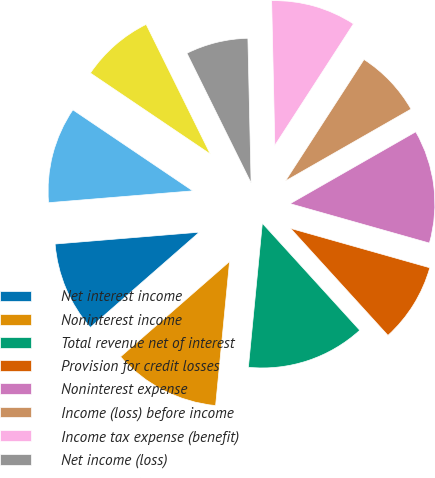Convert chart to OTSL. <chart><loc_0><loc_0><loc_500><loc_500><pie_chart><fcel>Net interest income<fcel>Noninterest income<fcel>Total revenue net of interest<fcel>Provision for credit losses<fcel>Noninterest expense<fcel>Income (loss) before income<fcel>Income tax expense (benefit)<fcel>Net income (loss)<fcel>Net income (loss) applicable<fcel>Average common shares issued<nl><fcel>10.13%<fcel>12.03%<fcel>13.29%<fcel>8.86%<fcel>12.66%<fcel>7.59%<fcel>9.49%<fcel>6.96%<fcel>8.23%<fcel>10.76%<nl></chart> 